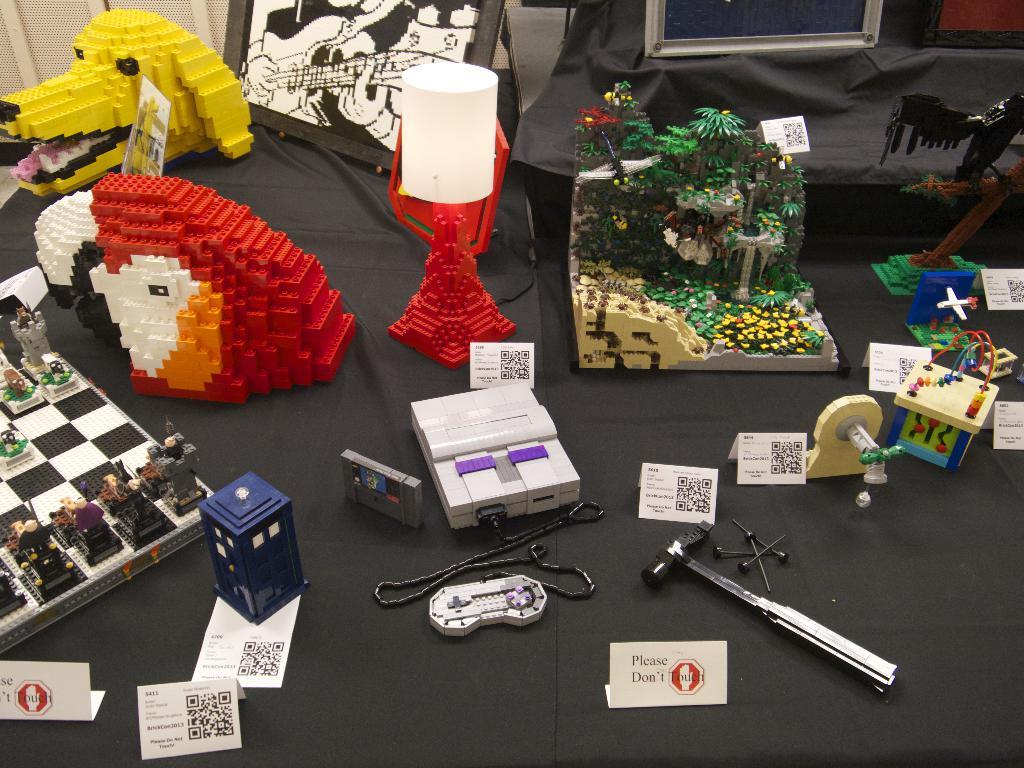What type of objects can be seen in the image? There are plastic toys, tools, and a lamp in the image. What living creature is present in the image? There is a dog in the image. What can be seen in the background of the image? There are trees and TVs in the background of the image. Where was the image taken? The image was taken in a hall. What type of muscle is being exercised by the dog in the image? There is no indication in the image that the dog is exercising any muscles. What color is the yarn used to create the plastic toys in the image? The image does not show the process of creating the plastic toys or any yarn being used. 